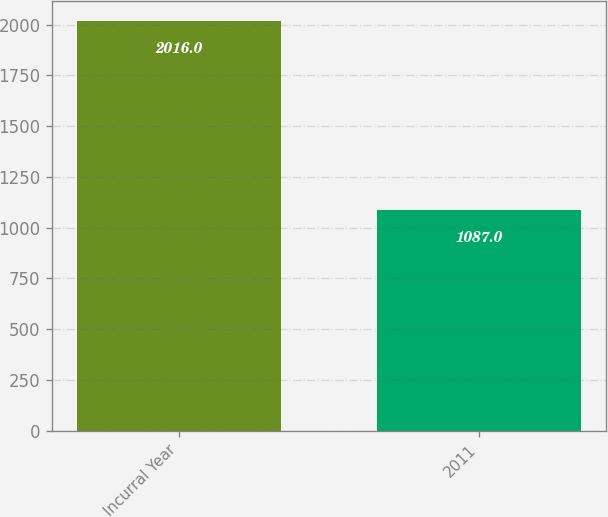<chart> <loc_0><loc_0><loc_500><loc_500><bar_chart><fcel>Incurral Year<fcel>2011<nl><fcel>2016<fcel>1087<nl></chart> 